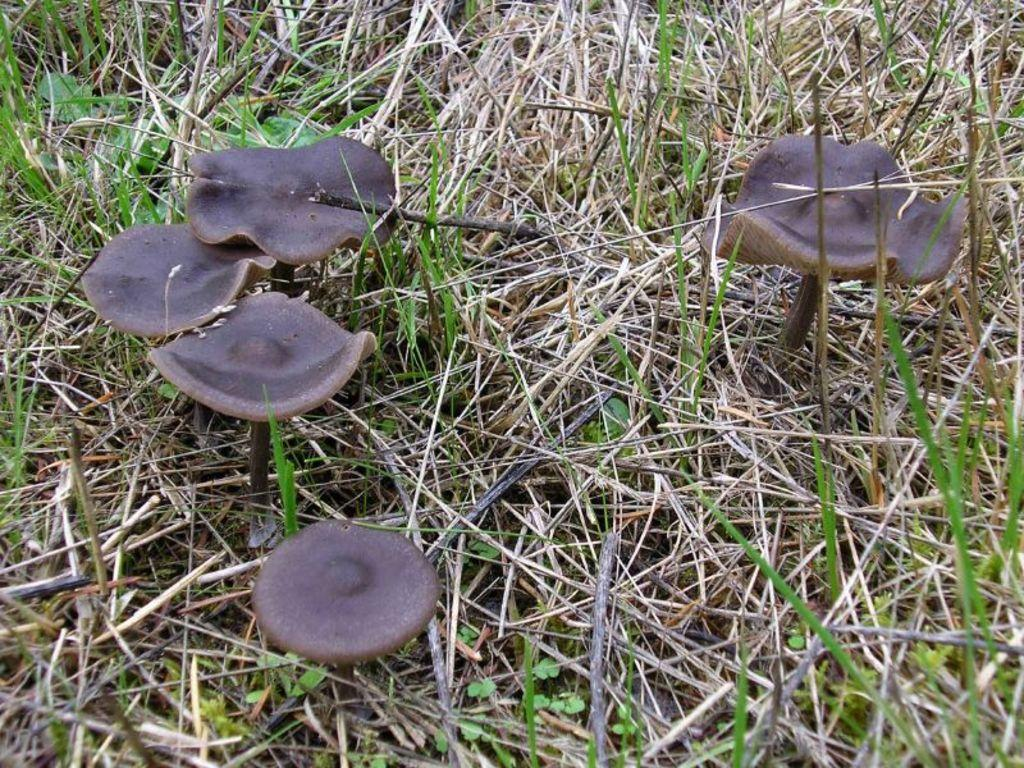What type of fungi can be seen in the image? There are mushrooms in the image. What type of vegetation is present around the mushrooms? There is grass around the mushrooms in the image. What type of paste is being used to hold the mushrooms together in the image? There is no paste present in the image, and the mushrooms are not being held together. 